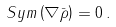<formula> <loc_0><loc_0><loc_500><loc_500>S y m \left ( \nabla \bar { \rho } \right ) = 0 \, .</formula> 